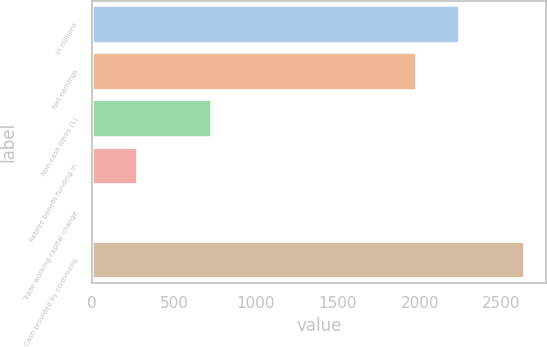Convert chart to OTSL. <chart><loc_0><loc_0><loc_500><loc_500><bar_chart><fcel>in millions<fcel>Net earnings<fcel>Non-cash items (1)<fcel>Retiree benefit funding in<fcel>Trade working capital change<fcel>Cash provided by continuing<nl><fcel>2241.3<fcel>1978<fcel>726<fcel>270.3<fcel>7<fcel>2640<nl></chart> 